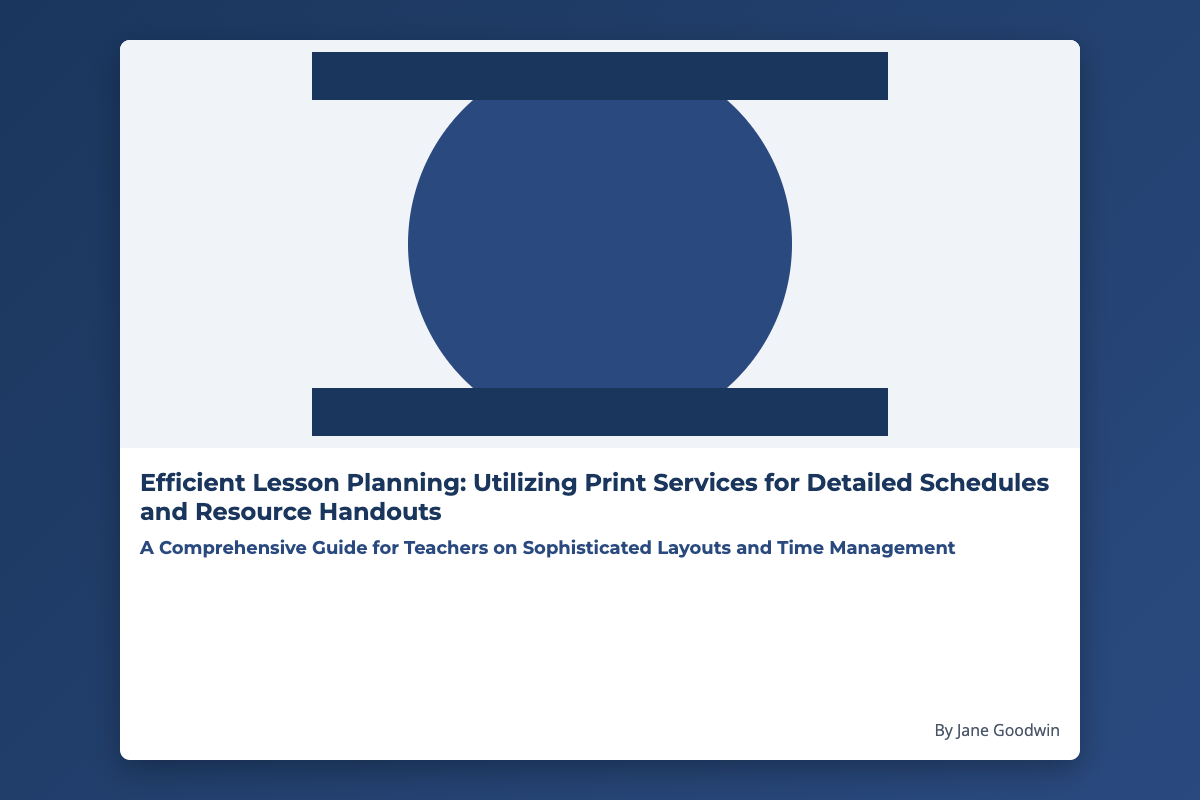What is the title of the book? The title can be found prominently displayed on the cover.
Answer: Efficient Lesson Planning: Utilizing Print Services for Detailed Schedules and Resource Handouts Who is the author of the book? The author's name is listed at the bottom of the cover.
Answer: Jane Goodwin What is the main focus of the book? The subtitle provides insight into the primary subject of the book.
Answer: A Comprehensive Guide for Teachers on Sophisticated Layouts and Time Management What color is the book cover's background? The background color is specified by the style defined in the document.
Answer: Gradient of dark blue What percentage of the cover is dedicated to the cover image? The layout details the specific area allocation on the cover.
Answer: 60% What type of guidance does the book offer? The subtitle mentions the book's guidance focus.
Answer: Lesson Planning What font is used for the main title? The font style for the title is defined in the CSS section of the document.
Answer: Montserrat How is the text layout organized on the cover? The structure of the cover text is described in the layout specifications.
Answer: Flex-column layout 